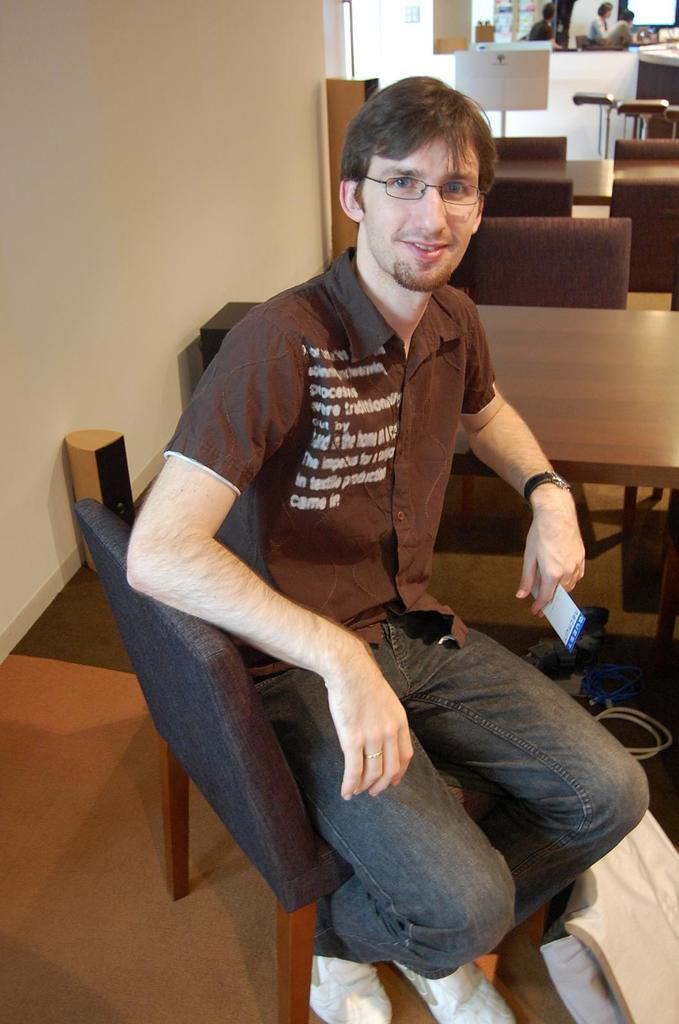What is the man in the image doing? The man is sitting on a chair in the image. What can be seen on the man's face in the image? The man is wearing glasses (specs) in the image. What can be seen in the background of the image? There are more chairs and people visible in the background of the image. How many trees are visible in the image? There are no trees visible in the image; it features a man sitting on a chair with a background of chairs and people. What time of day is depicted in the image? The provided facts do not give any information about the time of day, so it cannot be determined from the image. 